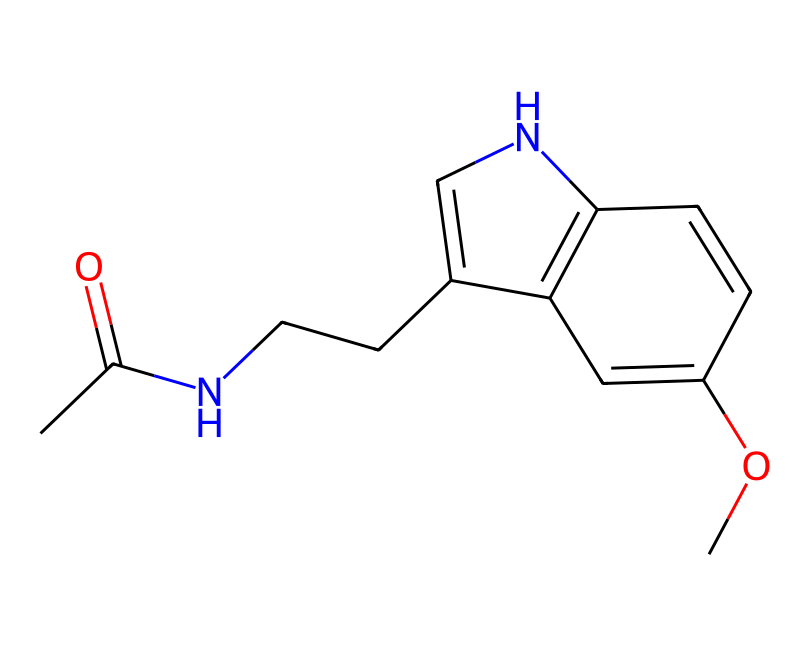How many carbon atoms are in the structure? By examining the SMILES representation, I can count the number of carbon atoms (C) present. Each "C" in the SMILES corresponds to a carbon atom, and there are 12 of them counted from the structure.
Answer: 12 What is the functional group present in melatonin? In the given SMILES, there is a carbonyl group (C=O) indicated by the "C(=O)" portion, which suggests the presence of an amide functional group due to the adjacent nitrogen atom (N).
Answer: amide How many double bonds are in the structure? Looking at the SMILES, I can identify the sections with "=" signs, which denote double bonds. There are four double bonds indicated in this structure.
Answer: 4 Which atom connects to the nitrogen in the carbon chain? The nitrogen (N) in the chain is directly connected to a carbon atom (C) that is part of the carbon chain next to it. Hence, the carbon chain connects to the nitrogen atom.
Answer: carbon What type of compound is melatonin classified as? Based on its structural components, melatonin can be categorized as an indole derivative due to the fused ring system in its structure, which is characteristic of this type.
Answer: indole derivative How many rings are present in the structure? Upon review of the SMILES representation, I can see two fused rings in the structure: one from the indole-like part and the other formed with the carbon chain and nitrogen, indicating a bicyclic structure.
Answer: 2 